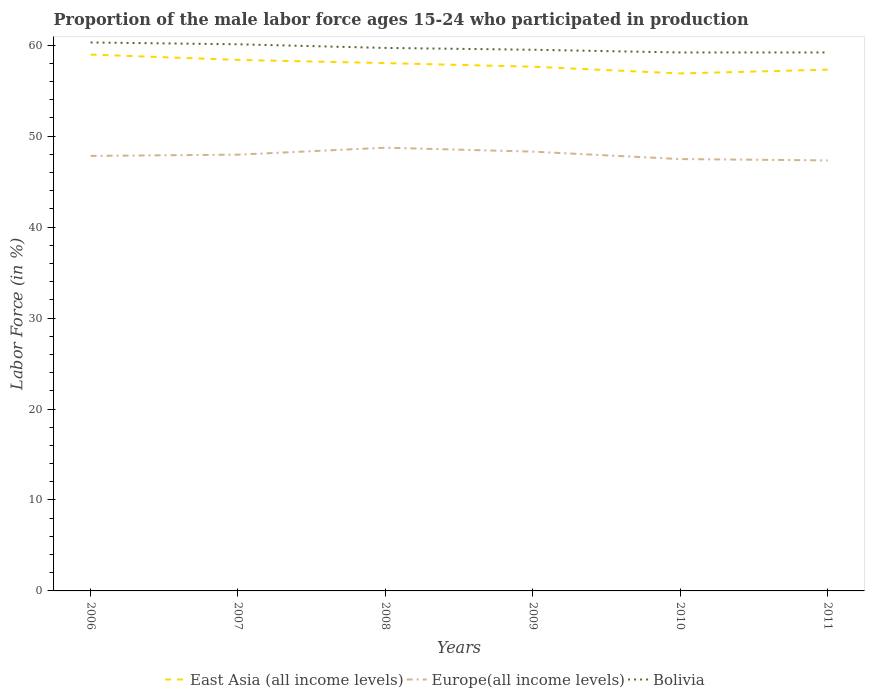How many different coloured lines are there?
Keep it short and to the point. 3. Across all years, what is the maximum proportion of the male labor force who participated in production in Bolivia?
Keep it short and to the point. 59.2. What is the total proportion of the male labor force who participated in production in Europe(all income levels) in the graph?
Offer a terse response. -0.14. What is the difference between the highest and the second highest proportion of the male labor force who participated in production in Europe(all income levels)?
Offer a very short reply. 1.4. How many years are there in the graph?
Your answer should be compact. 6. What is the difference between two consecutive major ticks on the Y-axis?
Offer a terse response. 10. Are the values on the major ticks of Y-axis written in scientific E-notation?
Your response must be concise. No. Does the graph contain grids?
Offer a terse response. No. What is the title of the graph?
Provide a short and direct response. Proportion of the male labor force ages 15-24 who participated in production. Does "Micronesia" appear as one of the legend labels in the graph?
Offer a terse response. No. What is the label or title of the Y-axis?
Provide a succinct answer. Labor Force (in %). What is the Labor Force (in %) of East Asia (all income levels) in 2006?
Offer a very short reply. 58.97. What is the Labor Force (in %) of Europe(all income levels) in 2006?
Ensure brevity in your answer.  47.83. What is the Labor Force (in %) of Bolivia in 2006?
Provide a succinct answer. 60.3. What is the Labor Force (in %) of East Asia (all income levels) in 2007?
Give a very brief answer. 58.38. What is the Labor Force (in %) of Europe(all income levels) in 2007?
Your answer should be very brief. 47.97. What is the Labor Force (in %) in Bolivia in 2007?
Keep it short and to the point. 60.1. What is the Labor Force (in %) in East Asia (all income levels) in 2008?
Keep it short and to the point. 58.03. What is the Labor Force (in %) of Europe(all income levels) in 2008?
Make the answer very short. 48.73. What is the Labor Force (in %) of Bolivia in 2008?
Your response must be concise. 59.7. What is the Labor Force (in %) of East Asia (all income levels) in 2009?
Provide a succinct answer. 57.64. What is the Labor Force (in %) of Europe(all income levels) in 2009?
Provide a short and direct response. 48.3. What is the Labor Force (in %) of Bolivia in 2009?
Offer a very short reply. 59.5. What is the Labor Force (in %) of East Asia (all income levels) in 2010?
Ensure brevity in your answer.  56.89. What is the Labor Force (in %) of Europe(all income levels) in 2010?
Your response must be concise. 47.48. What is the Labor Force (in %) in Bolivia in 2010?
Offer a very short reply. 59.2. What is the Labor Force (in %) of East Asia (all income levels) in 2011?
Give a very brief answer. 57.31. What is the Labor Force (in %) of Europe(all income levels) in 2011?
Your answer should be very brief. 47.33. What is the Labor Force (in %) of Bolivia in 2011?
Provide a succinct answer. 59.2. Across all years, what is the maximum Labor Force (in %) of East Asia (all income levels)?
Offer a very short reply. 58.97. Across all years, what is the maximum Labor Force (in %) in Europe(all income levels)?
Your answer should be very brief. 48.73. Across all years, what is the maximum Labor Force (in %) in Bolivia?
Your answer should be very brief. 60.3. Across all years, what is the minimum Labor Force (in %) of East Asia (all income levels)?
Keep it short and to the point. 56.89. Across all years, what is the minimum Labor Force (in %) in Europe(all income levels)?
Your answer should be compact. 47.33. Across all years, what is the minimum Labor Force (in %) in Bolivia?
Provide a succinct answer. 59.2. What is the total Labor Force (in %) in East Asia (all income levels) in the graph?
Your answer should be compact. 347.23. What is the total Labor Force (in %) in Europe(all income levels) in the graph?
Ensure brevity in your answer.  287.64. What is the total Labor Force (in %) in Bolivia in the graph?
Your answer should be compact. 358. What is the difference between the Labor Force (in %) of East Asia (all income levels) in 2006 and that in 2007?
Provide a succinct answer. 0.59. What is the difference between the Labor Force (in %) of Europe(all income levels) in 2006 and that in 2007?
Your response must be concise. -0.14. What is the difference between the Labor Force (in %) in East Asia (all income levels) in 2006 and that in 2008?
Offer a very short reply. 0.94. What is the difference between the Labor Force (in %) in Europe(all income levels) in 2006 and that in 2008?
Ensure brevity in your answer.  -0.9. What is the difference between the Labor Force (in %) of East Asia (all income levels) in 2006 and that in 2009?
Your response must be concise. 1.33. What is the difference between the Labor Force (in %) of Europe(all income levels) in 2006 and that in 2009?
Your answer should be very brief. -0.47. What is the difference between the Labor Force (in %) in East Asia (all income levels) in 2006 and that in 2010?
Ensure brevity in your answer.  2.07. What is the difference between the Labor Force (in %) in Europe(all income levels) in 2006 and that in 2010?
Your response must be concise. 0.35. What is the difference between the Labor Force (in %) of East Asia (all income levels) in 2006 and that in 2011?
Your response must be concise. 1.66. What is the difference between the Labor Force (in %) of Europe(all income levels) in 2006 and that in 2011?
Your response must be concise. 0.49. What is the difference between the Labor Force (in %) in East Asia (all income levels) in 2007 and that in 2008?
Provide a short and direct response. 0.35. What is the difference between the Labor Force (in %) of Europe(all income levels) in 2007 and that in 2008?
Your answer should be compact. -0.76. What is the difference between the Labor Force (in %) in East Asia (all income levels) in 2007 and that in 2009?
Ensure brevity in your answer.  0.75. What is the difference between the Labor Force (in %) in Europe(all income levels) in 2007 and that in 2009?
Offer a very short reply. -0.33. What is the difference between the Labor Force (in %) in East Asia (all income levels) in 2007 and that in 2010?
Offer a very short reply. 1.49. What is the difference between the Labor Force (in %) of Europe(all income levels) in 2007 and that in 2010?
Your response must be concise. 0.48. What is the difference between the Labor Force (in %) in Bolivia in 2007 and that in 2010?
Ensure brevity in your answer.  0.9. What is the difference between the Labor Force (in %) in East Asia (all income levels) in 2007 and that in 2011?
Make the answer very short. 1.07. What is the difference between the Labor Force (in %) in Europe(all income levels) in 2007 and that in 2011?
Your response must be concise. 0.63. What is the difference between the Labor Force (in %) in Bolivia in 2007 and that in 2011?
Ensure brevity in your answer.  0.9. What is the difference between the Labor Force (in %) in East Asia (all income levels) in 2008 and that in 2009?
Provide a succinct answer. 0.39. What is the difference between the Labor Force (in %) in Europe(all income levels) in 2008 and that in 2009?
Keep it short and to the point. 0.43. What is the difference between the Labor Force (in %) of Bolivia in 2008 and that in 2009?
Your answer should be compact. 0.2. What is the difference between the Labor Force (in %) in East Asia (all income levels) in 2008 and that in 2010?
Your response must be concise. 1.14. What is the difference between the Labor Force (in %) in Europe(all income levels) in 2008 and that in 2010?
Give a very brief answer. 1.25. What is the difference between the Labor Force (in %) in Bolivia in 2008 and that in 2010?
Your answer should be very brief. 0.5. What is the difference between the Labor Force (in %) in East Asia (all income levels) in 2008 and that in 2011?
Offer a terse response. 0.72. What is the difference between the Labor Force (in %) of Europe(all income levels) in 2008 and that in 2011?
Provide a succinct answer. 1.4. What is the difference between the Labor Force (in %) of East Asia (all income levels) in 2009 and that in 2010?
Provide a succinct answer. 0.74. What is the difference between the Labor Force (in %) in Europe(all income levels) in 2009 and that in 2010?
Make the answer very short. 0.82. What is the difference between the Labor Force (in %) of East Asia (all income levels) in 2009 and that in 2011?
Provide a succinct answer. 0.33. What is the difference between the Labor Force (in %) of Europe(all income levels) in 2009 and that in 2011?
Offer a terse response. 0.96. What is the difference between the Labor Force (in %) of Bolivia in 2009 and that in 2011?
Keep it short and to the point. 0.3. What is the difference between the Labor Force (in %) of East Asia (all income levels) in 2010 and that in 2011?
Your response must be concise. -0.42. What is the difference between the Labor Force (in %) in Europe(all income levels) in 2010 and that in 2011?
Ensure brevity in your answer.  0.15. What is the difference between the Labor Force (in %) in Bolivia in 2010 and that in 2011?
Make the answer very short. 0. What is the difference between the Labor Force (in %) of East Asia (all income levels) in 2006 and the Labor Force (in %) of Europe(all income levels) in 2007?
Keep it short and to the point. 11. What is the difference between the Labor Force (in %) in East Asia (all income levels) in 2006 and the Labor Force (in %) in Bolivia in 2007?
Your response must be concise. -1.13. What is the difference between the Labor Force (in %) in Europe(all income levels) in 2006 and the Labor Force (in %) in Bolivia in 2007?
Offer a terse response. -12.27. What is the difference between the Labor Force (in %) in East Asia (all income levels) in 2006 and the Labor Force (in %) in Europe(all income levels) in 2008?
Make the answer very short. 10.24. What is the difference between the Labor Force (in %) in East Asia (all income levels) in 2006 and the Labor Force (in %) in Bolivia in 2008?
Make the answer very short. -0.73. What is the difference between the Labor Force (in %) in Europe(all income levels) in 2006 and the Labor Force (in %) in Bolivia in 2008?
Your response must be concise. -11.87. What is the difference between the Labor Force (in %) of East Asia (all income levels) in 2006 and the Labor Force (in %) of Europe(all income levels) in 2009?
Your response must be concise. 10.67. What is the difference between the Labor Force (in %) of East Asia (all income levels) in 2006 and the Labor Force (in %) of Bolivia in 2009?
Provide a short and direct response. -0.53. What is the difference between the Labor Force (in %) of Europe(all income levels) in 2006 and the Labor Force (in %) of Bolivia in 2009?
Give a very brief answer. -11.67. What is the difference between the Labor Force (in %) in East Asia (all income levels) in 2006 and the Labor Force (in %) in Europe(all income levels) in 2010?
Make the answer very short. 11.49. What is the difference between the Labor Force (in %) in East Asia (all income levels) in 2006 and the Labor Force (in %) in Bolivia in 2010?
Keep it short and to the point. -0.23. What is the difference between the Labor Force (in %) of Europe(all income levels) in 2006 and the Labor Force (in %) of Bolivia in 2010?
Your answer should be very brief. -11.37. What is the difference between the Labor Force (in %) of East Asia (all income levels) in 2006 and the Labor Force (in %) of Europe(all income levels) in 2011?
Ensure brevity in your answer.  11.64. What is the difference between the Labor Force (in %) in East Asia (all income levels) in 2006 and the Labor Force (in %) in Bolivia in 2011?
Provide a succinct answer. -0.23. What is the difference between the Labor Force (in %) of Europe(all income levels) in 2006 and the Labor Force (in %) of Bolivia in 2011?
Provide a succinct answer. -11.37. What is the difference between the Labor Force (in %) in East Asia (all income levels) in 2007 and the Labor Force (in %) in Europe(all income levels) in 2008?
Your answer should be very brief. 9.65. What is the difference between the Labor Force (in %) in East Asia (all income levels) in 2007 and the Labor Force (in %) in Bolivia in 2008?
Your response must be concise. -1.32. What is the difference between the Labor Force (in %) in Europe(all income levels) in 2007 and the Labor Force (in %) in Bolivia in 2008?
Provide a succinct answer. -11.73. What is the difference between the Labor Force (in %) of East Asia (all income levels) in 2007 and the Labor Force (in %) of Europe(all income levels) in 2009?
Offer a terse response. 10.09. What is the difference between the Labor Force (in %) in East Asia (all income levels) in 2007 and the Labor Force (in %) in Bolivia in 2009?
Provide a succinct answer. -1.12. What is the difference between the Labor Force (in %) of Europe(all income levels) in 2007 and the Labor Force (in %) of Bolivia in 2009?
Provide a succinct answer. -11.53. What is the difference between the Labor Force (in %) of East Asia (all income levels) in 2007 and the Labor Force (in %) of Europe(all income levels) in 2010?
Provide a succinct answer. 10.9. What is the difference between the Labor Force (in %) in East Asia (all income levels) in 2007 and the Labor Force (in %) in Bolivia in 2010?
Ensure brevity in your answer.  -0.82. What is the difference between the Labor Force (in %) in Europe(all income levels) in 2007 and the Labor Force (in %) in Bolivia in 2010?
Keep it short and to the point. -11.23. What is the difference between the Labor Force (in %) of East Asia (all income levels) in 2007 and the Labor Force (in %) of Europe(all income levels) in 2011?
Your response must be concise. 11.05. What is the difference between the Labor Force (in %) in East Asia (all income levels) in 2007 and the Labor Force (in %) in Bolivia in 2011?
Provide a short and direct response. -0.82. What is the difference between the Labor Force (in %) of Europe(all income levels) in 2007 and the Labor Force (in %) of Bolivia in 2011?
Keep it short and to the point. -11.23. What is the difference between the Labor Force (in %) of East Asia (all income levels) in 2008 and the Labor Force (in %) of Europe(all income levels) in 2009?
Offer a very short reply. 9.73. What is the difference between the Labor Force (in %) in East Asia (all income levels) in 2008 and the Labor Force (in %) in Bolivia in 2009?
Offer a terse response. -1.47. What is the difference between the Labor Force (in %) in Europe(all income levels) in 2008 and the Labor Force (in %) in Bolivia in 2009?
Keep it short and to the point. -10.77. What is the difference between the Labor Force (in %) of East Asia (all income levels) in 2008 and the Labor Force (in %) of Europe(all income levels) in 2010?
Provide a short and direct response. 10.55. What is the difference between the Labor Force (in %) in East Asia (all income levels) in 2008 and the Labor Force (in %) in Bolivia in 2010?
Provide a short and direct response. -1.17. What is the difference between the Labor Force (in %) in Europe(all income levels) in 2008 and the Labor Force (in %) in Bolivia in 2010?
Keep it short and to the point. -10.47. What is the difference between the Labor Force (in %) of East Asia (all income levels) in 2008 and the Labor Force (in %) of Europe(all income levels) in 2011?
Your answer should be very brief. 10.7. What is the difference between the Labor Force (in %) of East Asia (all income levels) in 2008 and the Labor Force (in %) of Bolivia in 2011?
Offer a very short reply. -1.17. What is the difference between the Labor Force (in %) in Europe(all income levels) in 2008 and the Labor Force (in %) in Bolivia in 2011?
Your response must be concise. -10.47. What is the difference between the Labor Force (in %) of East Asia (all income levels) in 2009 and the Labor Force (in %) of Europe(all income levels) in 2010?
Keep it short and to the point. 10.15. What is the difference between the Labor Force (in %) in East Asia (all income levels) in 2009 and the Labor Force (in %) in Bolivia in 2010?
Ensure brevity in your answer.  -1.56. What is the difference between the Labor Force (in %) in Europe(all income levels) in 2009 and the Labor Force (in %) in Bolivia in 2010?
Provide a short and direct response. -10.9. What is the difference between the Labor Force (in %) in East Asia (all income levels) in 2009 and the Labor Force (in %) in Europe(all income levels) in 2011?
Offer a terse response. 10.3. What is the difference between the Labor Force (in %) in East Asia (all income levels) in 2009 and the Labor Force (in %) in Bolivia in 2011?
Offer a terse response. -1.56. What is the difference between the Labor Force (in %) of Europe(all income levels) in 2009 and the Labor Force (in %) of Bolivia in 2011?
Provide a short and direct response. -10.9. What is the difference between the Labor Force (in %) in East Asia (all income levels) in 2010 and the Labor Force (in %) in Europe(all income levels) in 2011?
Provide a succinct answer. 9.56. What is the difference between the Labor Force (in %) of East Asia (all income levels) in 2010 and the Labor Force (in %) of Bolivia in 2011?
Ensure brevity in your answer.  -2.31. What is the difference between the Labor Force (in %) in Europe(all income levels) in 2010 and the Labor Force (in %) in Bolivia in 2011?
Ensure brevity in your answer.  -11.72. What is the average Labor Force (in %) in East Asia (all income levels) per year?
Make the answer very short. 57.87. What is the average Labor Force (in %) of Europe(all income levels) per year?
Make the answer very short. 47.94. What is the average Labor Force (in %) of Bolivia per year?
Make the answer very short. 59.67. In the year 2006, what is the difference between the Labor Force (in %) in East Asia (all income levels) and Labor Force (in %) in Europe(all income levels)?
Your response must be concise. 11.14. In the year 2006, what is the difference between the Labor Force (in %) in East Asia (all income levels) and Labor Force (in %) in Bolivia?
Ensure brevity in your answer.  -1.33. In the year 2006, what is the difference between the Labor Force (in %) of Europe(all income levels) and Labor Force (in %) of Bolivia?
Offer a terse response. -12.47. In the year 2007, what is the difference between the Labor Force (in %) of East Asia (all income levels) and Labor Force (in %) of Europe(all income levels)?
Your response must be concise. 10.42. In the year 2007, what is the difference between the Labor Force (in %) in East Asia (all income levels) and Labor Force (in %) in Bolivia?
Make the answer very short. -1.72. In the year 2007, what is the difference between the Labor Force (in %) in Europe(all income levels) and Labor Force (in %) in Bolivia?
Offer a very short reply. -12.13. In the year 2008, what is the difference between the Labor Force (in %) in East Asia (all income levels) and Labor Force (in %) in Europe(all income levels)?
Your answer should be very brief. 9.3. In the year 2008, what is the difference between the Labor Force (in %) in East Asia (all income levels) and Labor Force (in %) in Bolivia?
Ensure brevity in your answer.  -1.67. In the year 2008, what is the difference between the Labor Force (in %) of Europe(all income levels) and Labor Force (in %) of Bolivia?
Offer a very short reply. -10.97. In the year 2009, what is the difference between the Labor Force (in %) in East Asia (all income levels) and Labor Force (in %) in Europe(all income levels)?
Offer a terse response. 9.34. In the year 2009, what is the difference between the Labor Force (in %) in East Asia (all income levels) and Labor Force (in %) in Bolivia?
Offer a very short reply. -1.86. In the year 2009, what is the difference between the Labor Force (in %) in Europe(all income levels) and Labor Force (in %) in Bolivia?
Your answer should be compact. -11.2. In the year 2010, what is the difference between the Labor Force (in %) of East Asia (all income levels) and Labor Force (in %) of Europe(all income levels)?
Your answer should be compact. 9.41. In the year 2010, what is the difference between the Labor Force (in %) of East Asia (all income levels) and Labor Force (in %) of Bolivia?
Provide a short and direct response. -2.31. In the year 2010, what is the difference between the Labor Force (in %) in Europe(all income levels) and Labor Force (in %) in Bolivia?
Your response must be concise. -11.72. In the year 2011, what is the difference between the Labor Force (in %) of East Asia (all income levels) and Labor Force (in %) of Europe(all income levels)?
Provide a short and direct response. 9.98. In the year 2011, what is the difference between the Labor Force (in %) of East Asia (all income levels) and Labor Force (in %) of Bolivia?
Your answer should be compact. -1.89. In the year 2011, what is the difference between the Labor Force (in %) of Europe(all income levels) and Labor Force (in %) of Bolivia?
Offer a terse response. -11.87. What is the ratio of the Labor Force (in %) of East Asia (all income levels) in 2006 to that in 2007?
Make the answer very short. 1.01. What is the ratio of the Labor Force (in %) of Bolivia in 2006 to that in 2007?
Offer a terse response. 1. What is the ratio of the Labor Force (in %) in East Asia (all income levels) in 2006 to that in 2008?
Your answer should be compact. 1.02. What is the ratio of the Labor Force (in %) of Europe(all income levels) in 2006 to that in 2008?
Your answer should be compact. 0.98. What is the ratio of the Labor Force (in %) in Bolivia in 2006 to that in 2008?
Give a very brief answer. 1.01. What is the ratio of the Labor Force (in %) in East Asia (all income levels) in 2006 to that in 2009?
Provide a short and direct response. 1.02. What is the ratio of the Labor Force (in %) of Europe(all income levels) in 2006 to that in 2009?
Offer a terse response. 0.99. What is the ratio of the Labor Force (in %) in Bolivia in 2006 to that in 2009?
Keep it short and to the point. 1.01. What is the ratio of the Labor Force (in %) in East Asia (all income levels) in 2006 to that in 2010?
Offer a terse response. 1.04. What is the ratio of the Labor Force (in %) of Europe(all income levels) in 2006 to that in 2010?
Keep it short and to the point. 1.01. What is the ratio of the Labor Force (in %) in Bolivia in 2006 to that in 2010?
Your response must be concise. 1.02. What is the ratio of the Labor Force (in %) in East Asia (all income levels) in 2006 to that in 2011?
Keep it short and to the point. 1.03. What is the ratio of the Labor Force (in %) of Europe(all income levels) in 2006 to that in 2011?
Make the answer very short. 1.01. What is the ratio of the Labor Force (in %) of Bolivia in 2006 to that in 2011?
Offer a very short reply. 1.02. What is the ratio of the Labor Force (in %) of East Asia (all income levels) in 2007 to that in 2008?
Your answer should be compact. 1.01. What is the ratio of the Labor Force (in %) of Europe(all income levels) in 2007 to that in 2008?
Offer a terse response. 0.98. What is the ratio of the Labor Force (in %) of Bolivia in 2007 to that in 2008?
Make the answer very short. 1.01. What is the ratio of the Labor Force (in %) of East Asia (all income levels) in 2007 to that in 2009?
Ensure brevity in your answer.  1.01. What is the ratio of the Labor Force (in %) of East Asia (all income levels) in 2007 to that in 2010?
Your answer should be very brief. 1.03. What is the ratio of the Labor Force (in %) in Europe(all income levels) in 2007 to that in 2010?
Give a very brief answer. 1.01. What is the ratio of the Labor Force (in %) of Bolivia in 2007 to that in 2010?
Offer a very short reply. 1.02. What is the ratio of the Labor Force (in %) in East Asia (all income levels) in 2007 to that in 2011?
Provide a short and direct response. 1.02. What is the ratio of the Labor Force (in %) of Europe(all income levels) in 2007 to that in 2011?
Provide a short and direct response. 1.01. What is the ratio of the Labor Force (in %) of Bolivia in 2007 to that in 2011?
Ensure brevity in your answer.  1.02. What is the ratio of the Labor Force (in %) of East Asia (all income levels) in 2008 to that in 2009?
Make the answer very short. 1.01. What is the ratio of the Labor Force (in %) in Europe(all income levels) in 2008 to that in 2009?
Make the answer very short. 1.01. What is the ratio of the Labor Force (in %) in East Asia (all income levels) in 2008 to that in 2010?
Make the answer very short. 1.02. What is the ratio of the Labor Force (in %) in Europe(all income levels) in 2008 to that in 2010?
Ensure brevity in your answer.  1.03. What is the ratio of the Labor Force (in %) of Bolivia in 2008 to that in 2010?
Ensure brevity in your answer.  1.01. What is the ratio of the Labor Force (in %) of East Asia (all income levels) in 2008 to that in 2011?
Offer a very short reply. 1.01. What is the ratio of the Labor Force (in %) in Europe(all income levels) in 2008 to that in 2011?
Your answer should be very brief. 1.03. What is the ratio of the Labor Force (in %) of Bolivia in 2008 to that in 2011?
Give a very brief answer. 1.01. What is the ratio of the Labor Force (in %) of East Asia (all income levels) in 2009 to that in 2010?
Make the answer very short. 1.01. What is the ratio of the Labor Force (in %) of Europe(all income levels) in 2009 to that in 2010?
Provide a short and direct response. 1.02. What is the ratio of the Labor Force (in %) of East Asia (all income levels) in 2009 to that in 2011?
Provide a short and direct response. 1.01. What is the ratio of the Labor Force (in %) of Europe(all income levels) in 2009 to that in 2011?
Your answer should be compact. 1.02. What is the ratio of the Labor Force (in %) of Bolivia in 2009 to that in 2011?
Your response must be concise. 1.01. What is the ratio of the Labor Force (in %) in Europe(all income levels) in 2010 to that in 2011?
Offer a very short reply. 1. What is the difference between the highest and the second highest Labor Force (in %) in East Asia (all income levels)?
Offer a very short reply. 0.59. What is the difference between the highest and the second highest Labor Force (in %) in Europe(all income levels)?
Keep it short and to the point. 0.43. What is the difference between the highest and the second highest Labor Force (in %) of Bolivia?
Keep it short and to the point. 0.2. What is the difference between the highest and the lowest Labor Force (in %) in East Asia (all income levels)?
Offer a very short reply. 2.07. What is the difference between the highest and the lowest Labor Force (in %) in Europe(all income levels)?
Give a very brief answer. 1.4. 